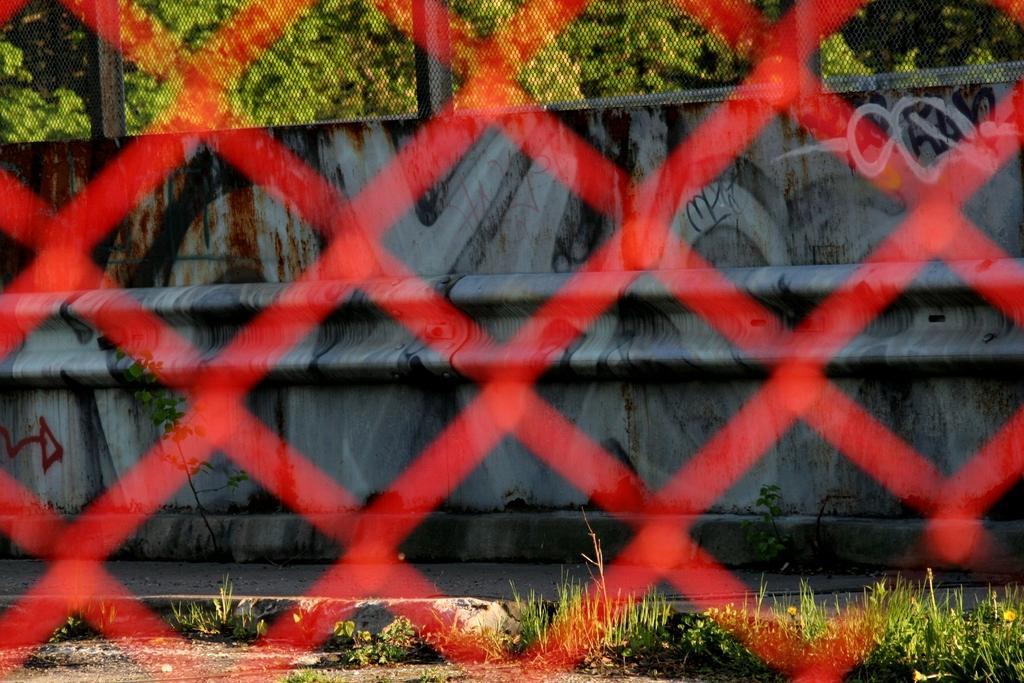Describe this image in one or two sentences. In the foreground of the picture there is net, it is blurred. In the background there are plants, shrubs, wall and trees. 